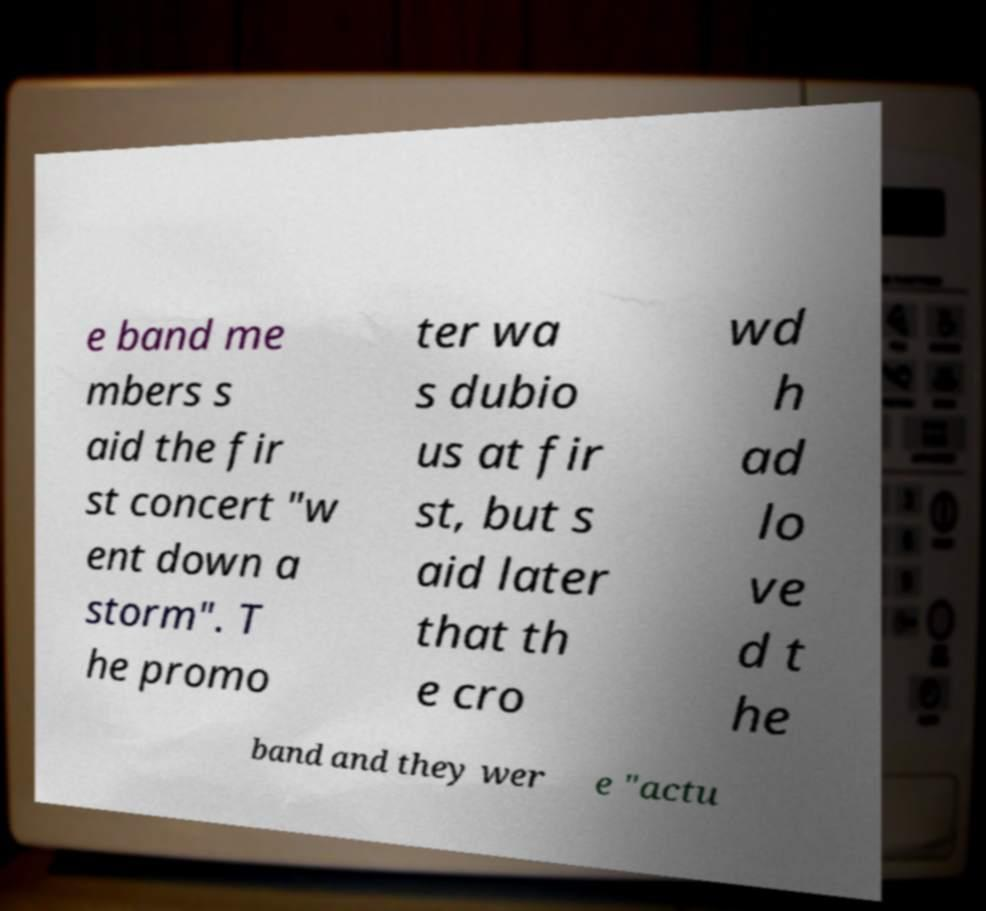Can you read and provide the text displayed in the image?This photo seems to have some interesting text. Can you extract and type it out for me? e band me mbers s aid the fir st concert "w ent down a storm". T he promo ter wa s dubio us at fir st, but s aid later that th e cro wd h ad lo ve d t he band and they wer e "actu 